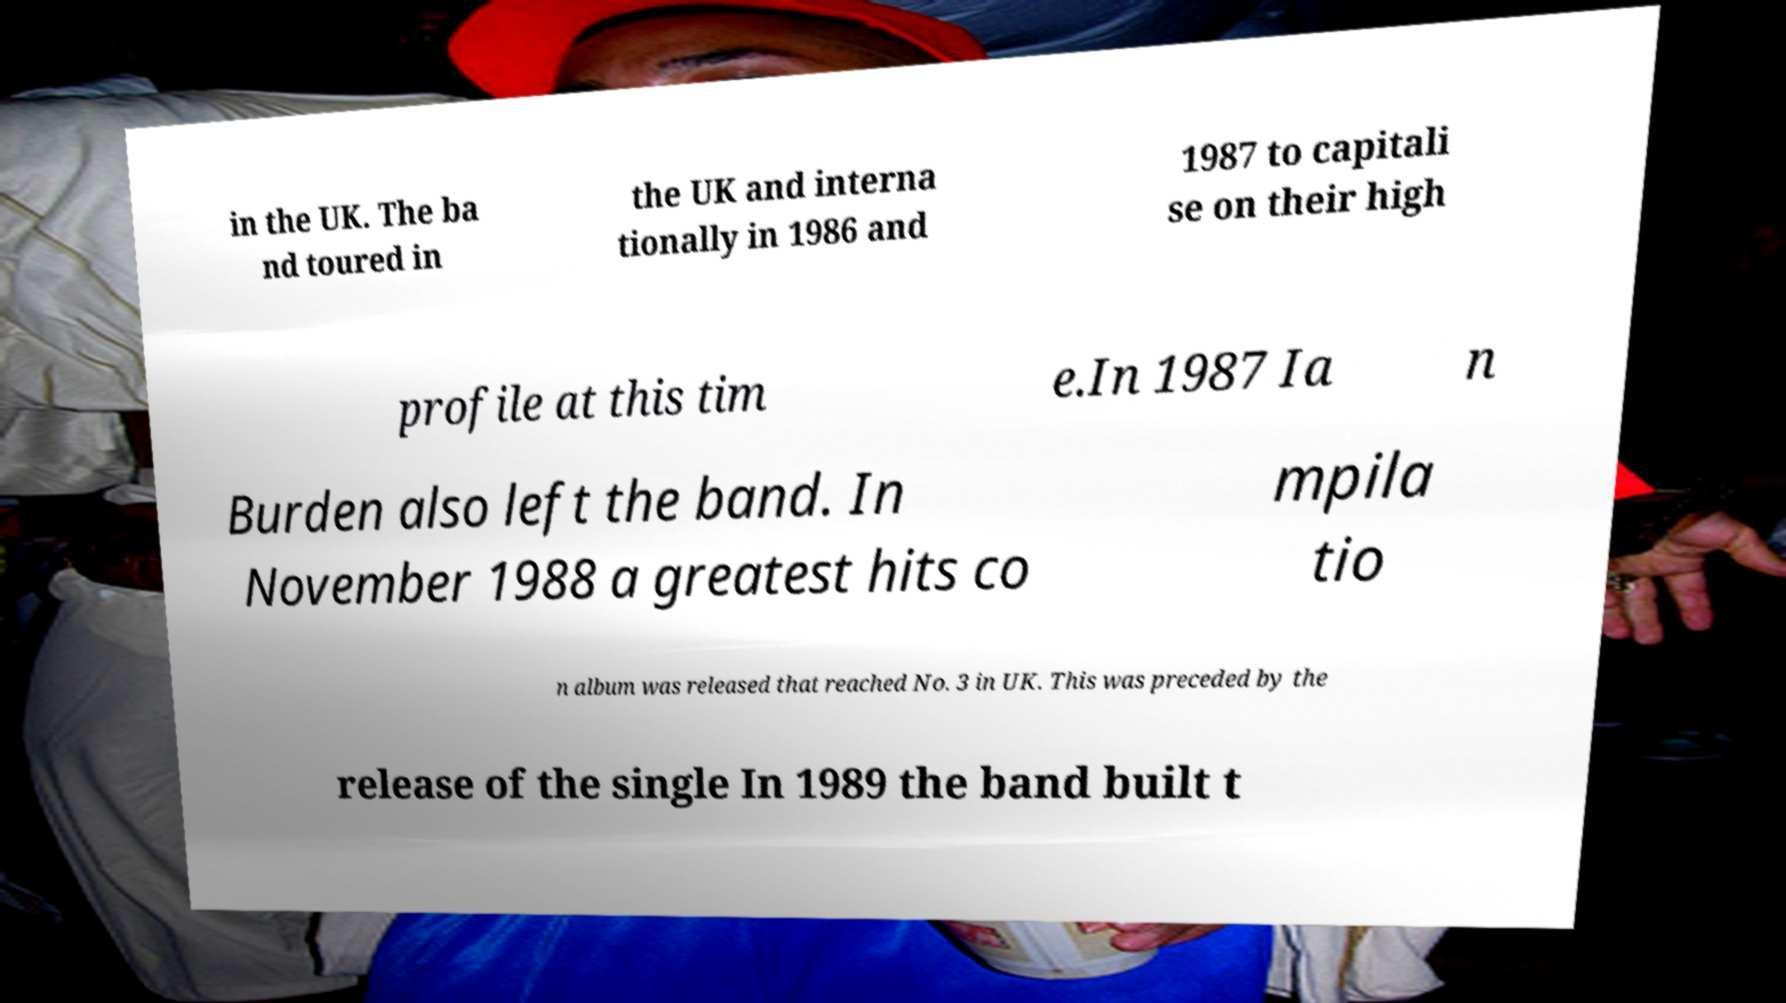Can you accurately transcribe the text from the provided image for me? in the UK. The ba nd toured in the UK and interna tionally in 1986 and 1987 to capitali se on their high profile at this tim e.In 1987 Ia n Burden also left the band. In November 1988 a greatest hits co mpila tio n album was released that reached No. 3 in UK. This was preceded by the release of the single In 1989 the band built t 